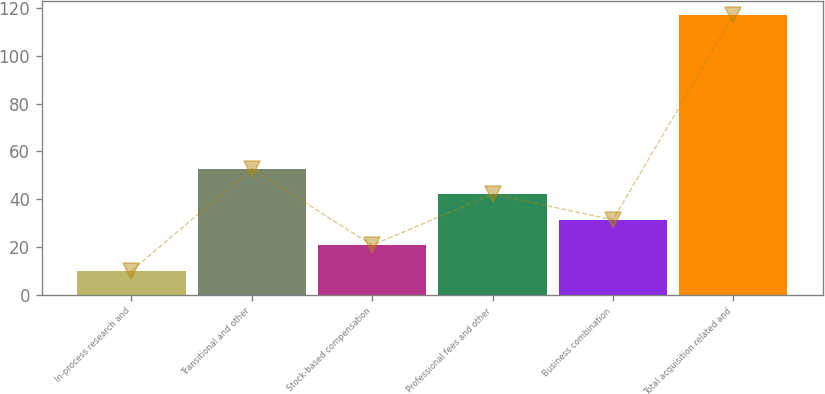Convert chart to OTSL. <chart><loc_0><loc_0><loc_500><loc_500><bar_chart><fcel>In-process research and<fcel>Transitional and other<fcel>Stock-based compensation<fcel>Professional fees and other<fcel>Business combination<fcel>Total acquisition related and<nl><fcel>10<fcel>52.8<fcel>20.7<fcel>42.1<fcel>31.4<fcel>117<nl></chart> 